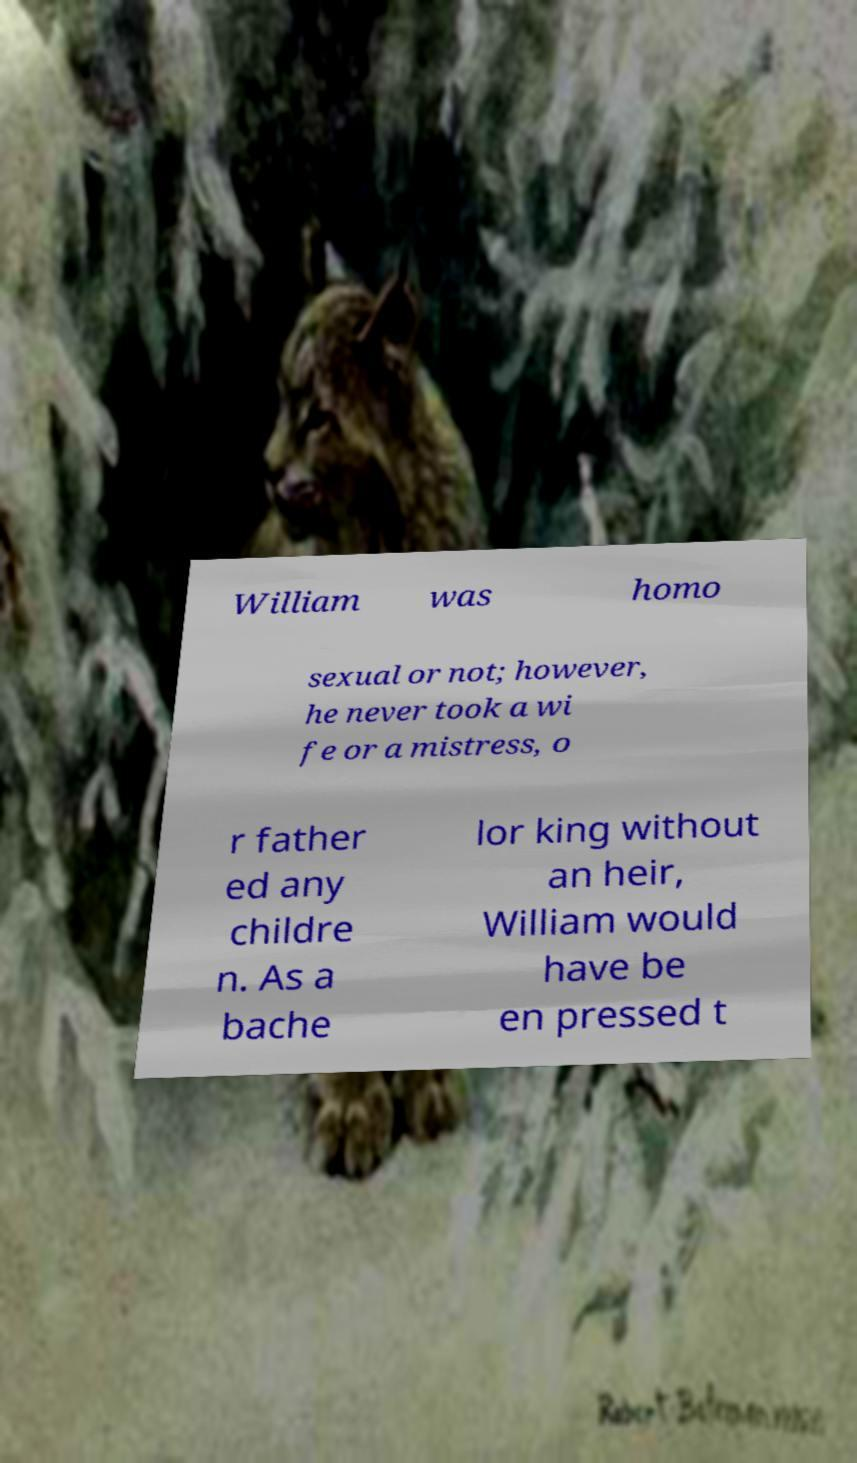I need the written content from this picture converted into text. Can you do that? William was homo sexual or not; however, he never took a wi fe or a mistress, o r father ed any childre n. As a bache lor king without an heir, William would have be en pressed t 